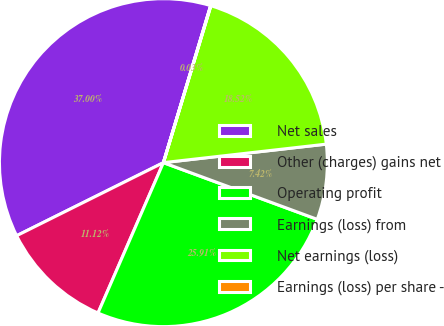<chart> <loc_0><loc_0><loc_500><loc_500><pie_chart><fcel>Net sales<fcel>Other (charges) gains net<fcel>Operating profit<fcel>Earnings (loss) from<fcel>Net earnings (loss)<fcel>Earnings (loss) per share -<nl><fcel>37.0%<fcel>11.12%<fcel>25.91%<fcel>7.42%<fcel>18.52%<fcel>0.03%<nl></chart> 